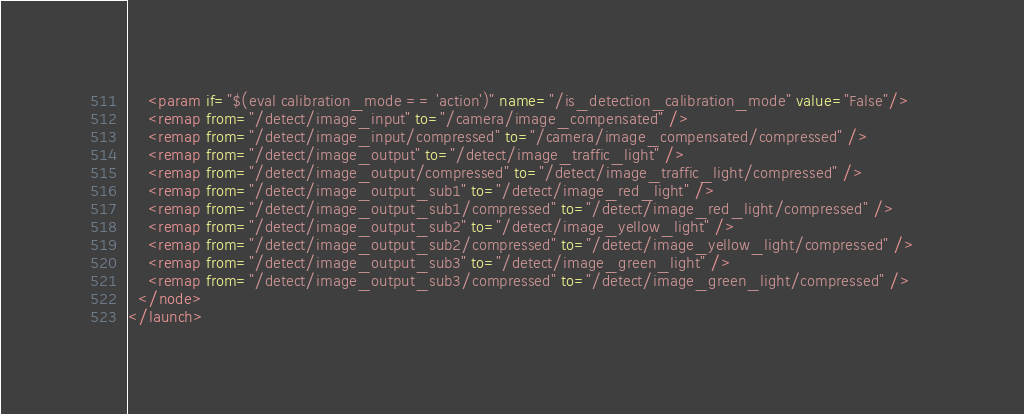Convert code to text. <code><loc_0><loc_0><loc_500><loc_500><_XML_>    <param if="$(eval calibration_mode == 'action')" name="/is_detection_calibration_mode" value="False"/>     
    <remap from="/detect/image_input" to="/camera/image_compensated" />
    <remap from="/detect/image_input/compressed" to="/camera/image_compensated/compressed" />
    <remap from="/detect/image_output" to="/detect/image_traffic_light" />
    <remap from="/detect/image_output/compressed" to="/detect/image_traffic_light/compressed" />
    <remap from="/detect/image_output_sub1" to="/detect/image_red_light" />
    <remap from="/detect/image_output_sub1/compressed" to="/detect/image_red_light/compressed" />
    <remap from="/detect/image_output_sub2" to="/detect/image_yellow_light" />
    <remap from="/detect/image_output_sub2/compressed" to="/detect/image_yellow_light/compressed" />
    <remap from="/detect/image_output_sub3" to="/detect/image_green_light" />
    <remap from="/detect/image_output_sub3/compressed" to="/detect/image_green_light/compressed" />  
  </node>
</launch></code> 